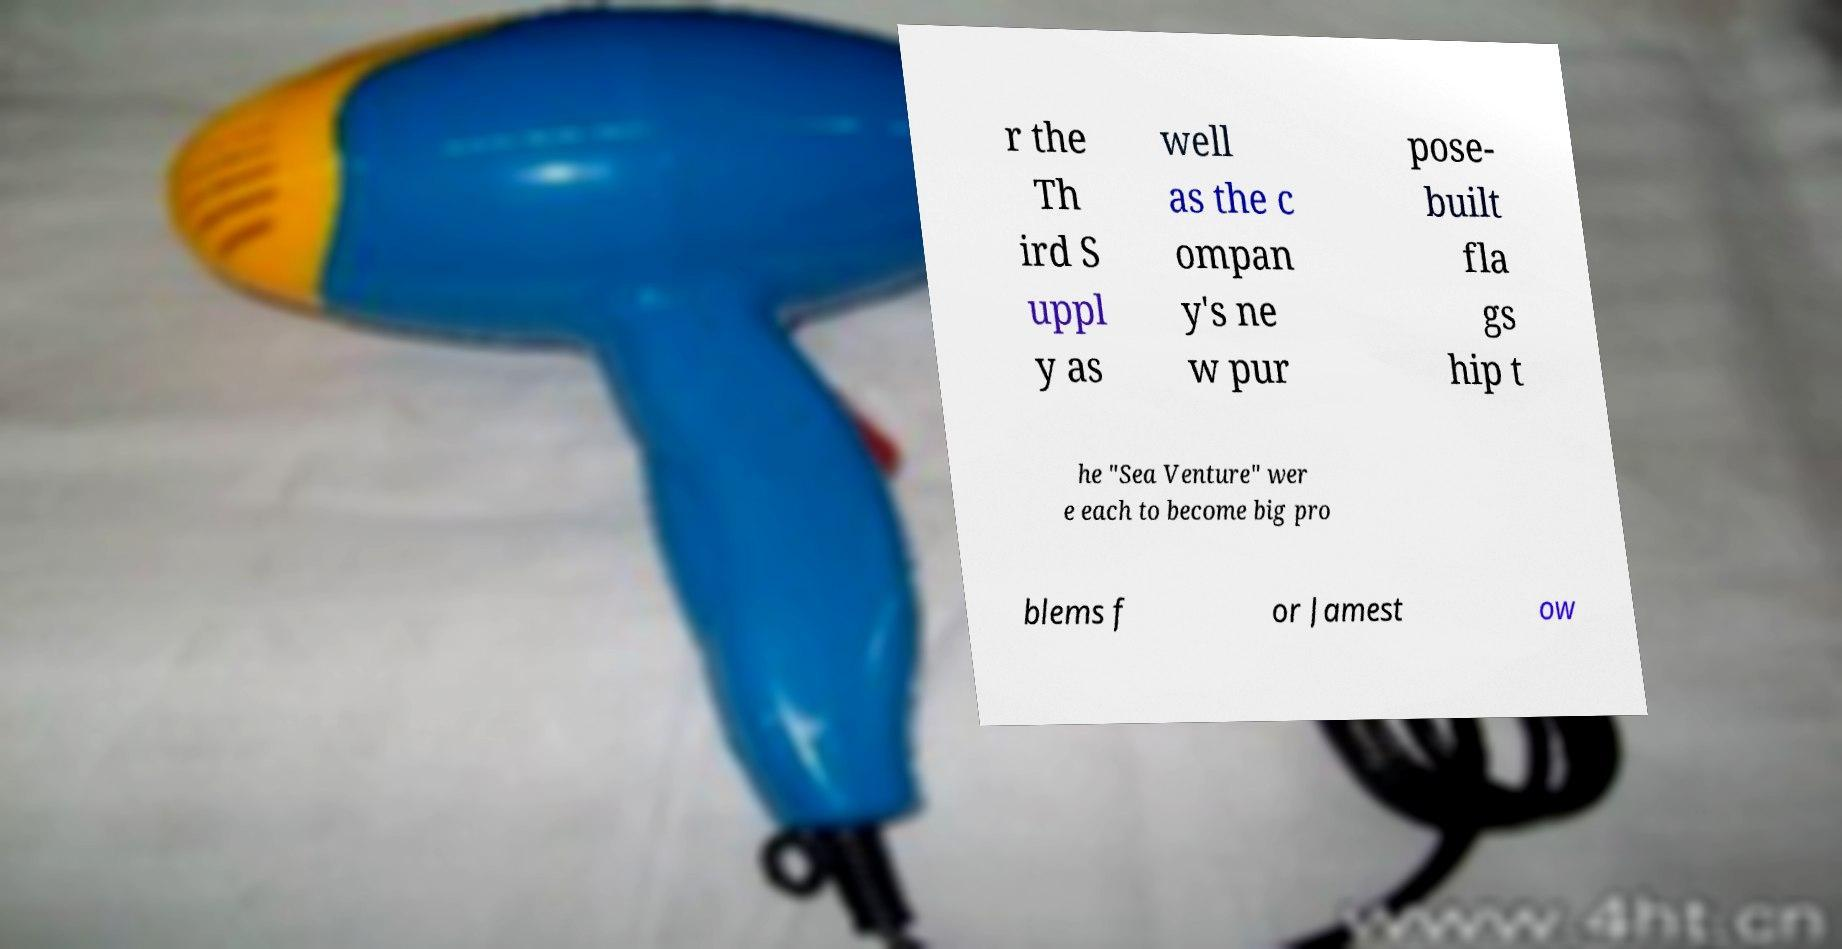Could you extract and type out the text from this image? r the Th ird S uppl y as well as the c ompan y's ne w pur pose- built fla gs hip t he "Sea Venture" wer e each to become big pro blems f or Jamest ow 